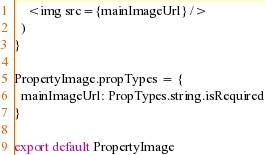<code> <loc_0><loc_0><loc_500><loc_500><_JavaScript_>    <img src={mainImageUrl} />
  )
}

PropertyImage.propTypes = {
  mainImageUrl: PropTypes.string.isRequired
}

export default PropertyImage</code> 